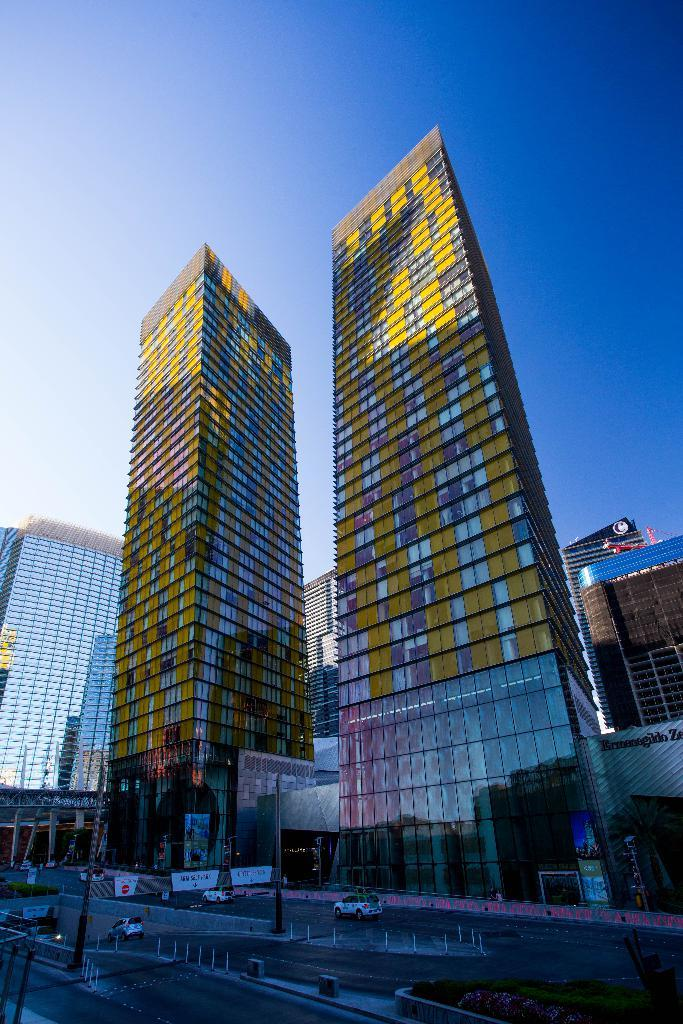What type of structures can be seen in the image? There are multiple buildings in the image. What is located at the bottom of the image? A road is visible at the bottom of the image. What is happening on the road? Cars are moving on the road. What color is the sky in the image? The sky is blue in color. How many boys are playing soccer in the image? There are no boys or soccer game present in the image. 